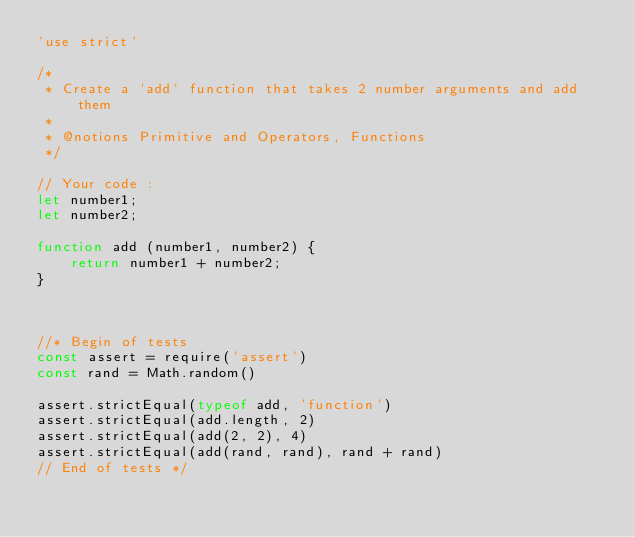<code> <loc_0><loc_0><loc_500><loc_500><_JavaScript_>'use strict'

/*
 * Create a `add` function that takes 2 number arguments and add them
 *
 * @notions Primitive and Operators, Functions
 */

// Your code :
let number1;
let number2;

function add (number1, number2) {
    return number1 + number2;
}



//* Begin of tests
const assert = require('assert')
const rand = Math.random()

assert.strictEqual(typeof add, 'function')
assert.strictEqual(add.length, 2)
assert.strictEqual(add(2, 2), 4)
assert.strictEqual(add(rand, rand), rand + rand)
// End of tests */
</code> 